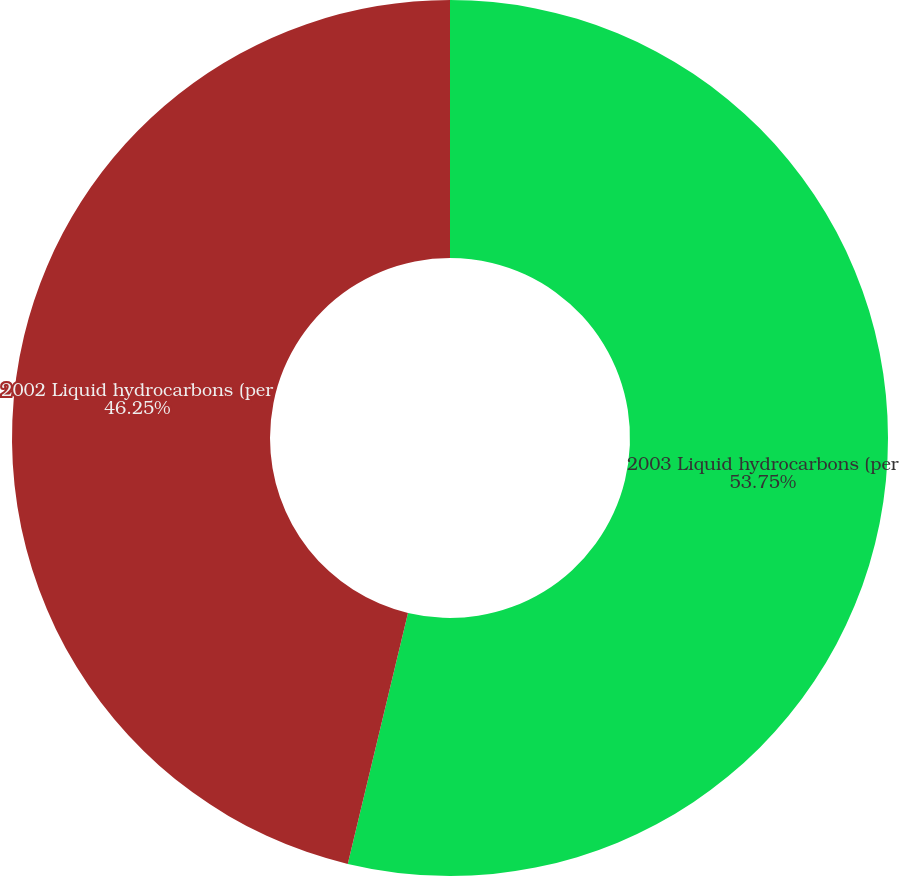Convert chart to OTSL. <chart><loc_0><loc_0><loc_500><loc_500><pie_chart><fcel>2003 Liquid hydrocarbons (per<fcel>2002 Liquid hydrocarbons (per<nl><fcel>53.75%<fcel>46.25%<nl></chart> 